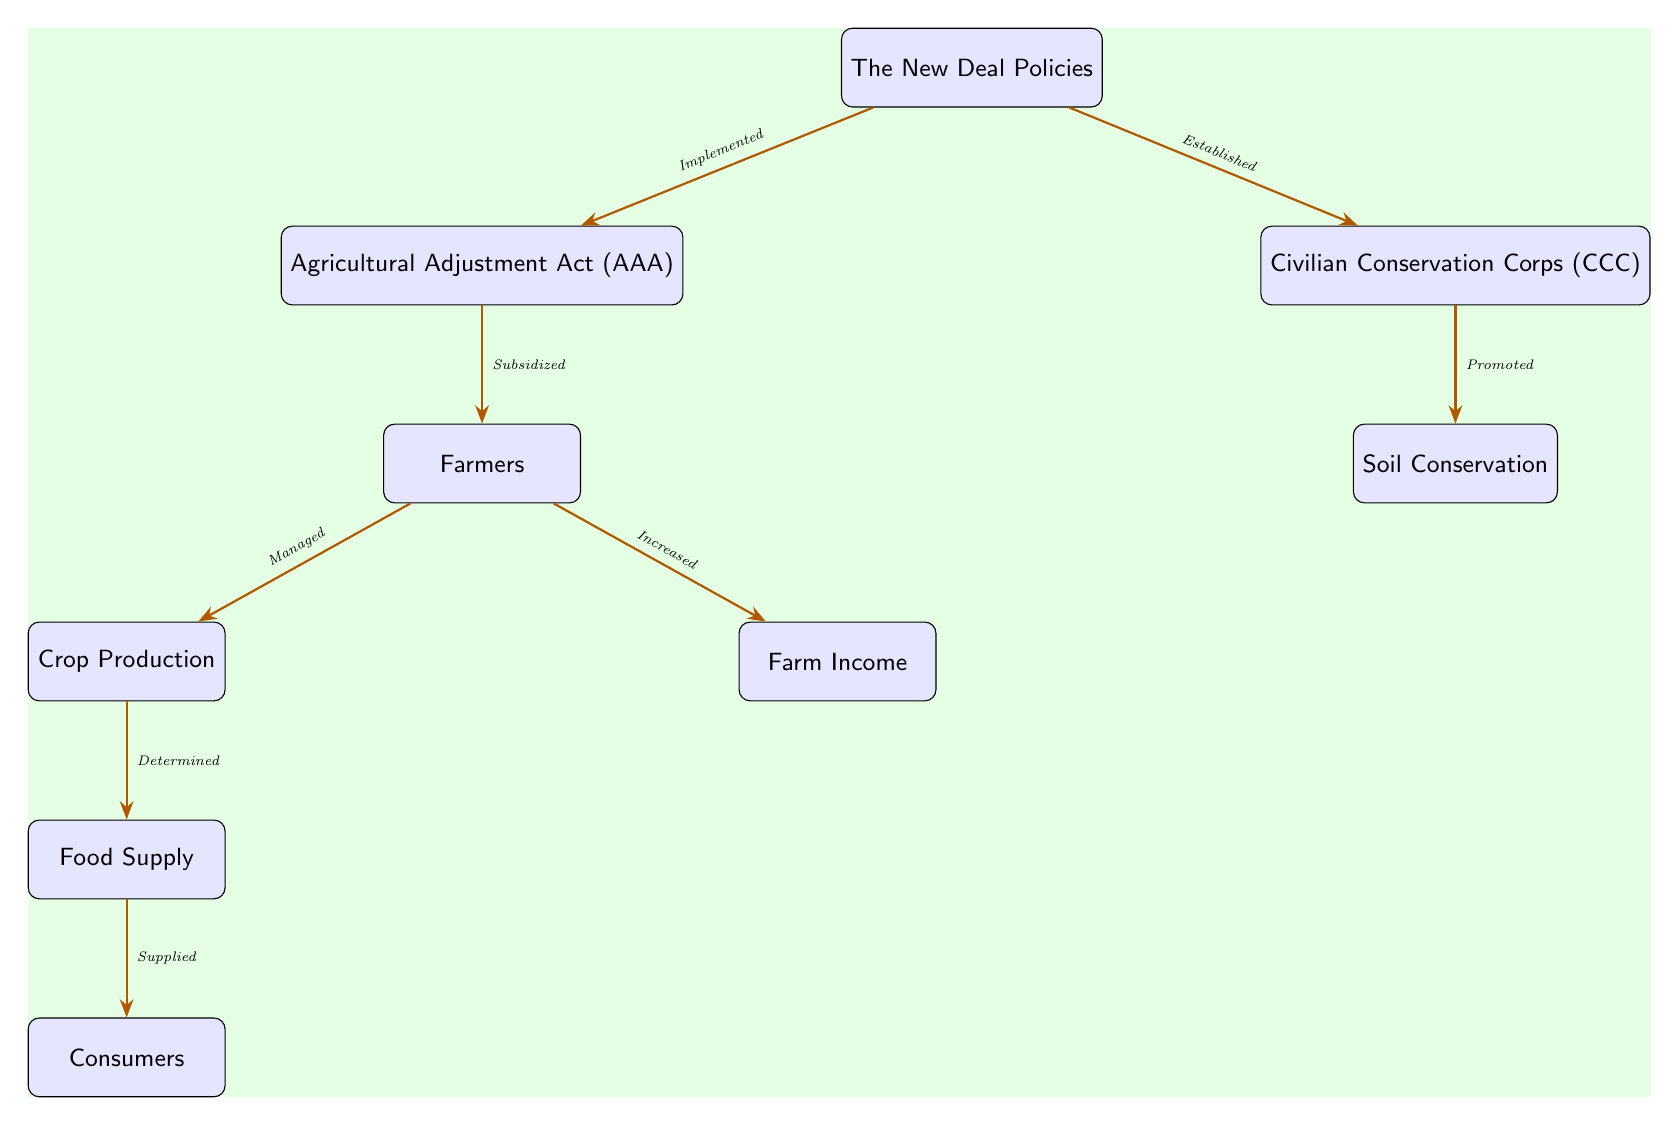What is the top node in the diagram? The top node represents the main theme of the diagram which is "The New Deal Policies."
Answer: The New Deal Policies How many nodes are present in the diagram? By counting each box in the diagram, we find a total of eight distinct nodes.
Answer: 8 Which node directly connects to the "Farmers" node? The "Farmers" node is directly connected to the "Agricultural Adjustment Act (AAA)" node, indicating their relationship.
Answer: Agricultural Adjustment Act (AAA) What action is indicated between "Crop Production" and "Food Supply"? The arrow indicates that "Crop Production" is determining the "Food Supply," which shows their cause-and-effect relationship.
Answer: Determined What is the relationship between "Civilian Conservation Corps (CCC)" and "Soil Conservation"? The relationship described is that the "Civilian Conservation Corps (CCC)" promotes "Soil Conservation."
Answer: Promoted Identify a policy that subsidizes farmers. The "Agricultural Adjustment Act (AAA)" is the policy that provides subsidies to farmers as shown in the diagram.
Answer: Agricultural Adjustment Act (AAA) How do the "Farm Income" and "Consumers" nodes relate through the diagram? The flow indicates that "Farm Income" increases as a result of the actions taken, which ultimately supplies "Consumers" with food, creating a pathway from income to consumption.
Answer: Supplied What is the main function of the "Soil Conservation" node in the diagram? The "Soil Conservation" node serves to support the sustainability of agricultural practices as promoted by the "Civilian Conservation Corps (CCC)."
Answer: Soil Conservation What determines the "Food Supply" in the diagram? "Crop Production" is the determining factor for the "Food Supply," as linked by the corresponding arrow in the diagram.
Answer: Crop Production 